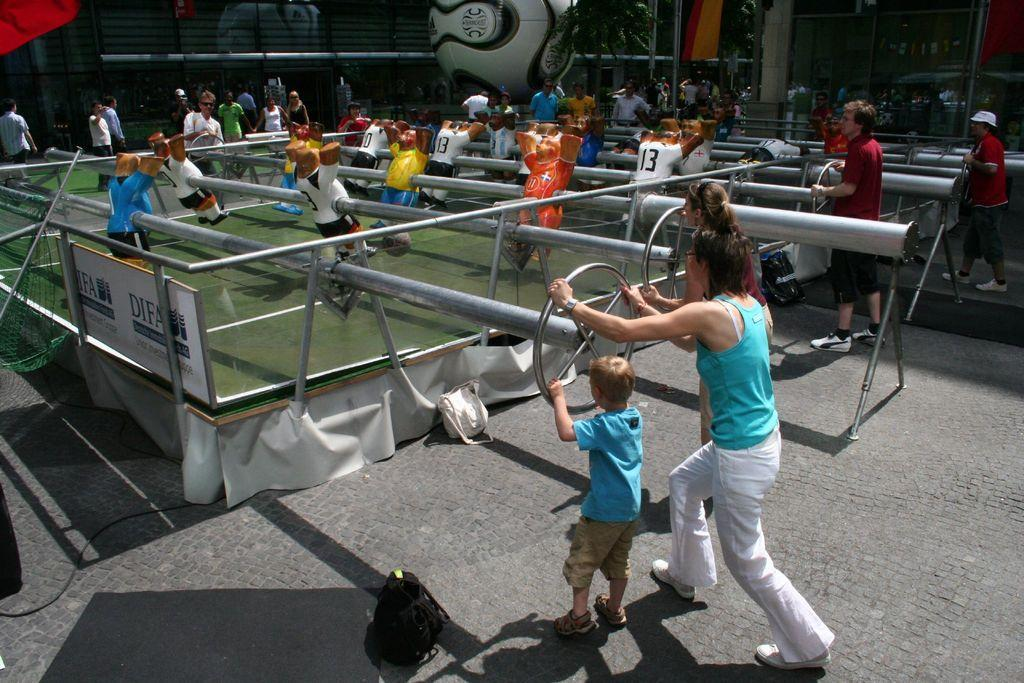How many people are in the image? There is a group of people in the image, but the exact number is not specified. What are the people doing in the image? Some people are playing a game, while others are holding metal rods. What can be seen in the background of the image? There is a tree and buildings in the background of the image. What object is present in the image that is commonly used in games? There is a ball in the image. What direction is the fog coming from in the image? There is no fog present in the image, so it is not possible to determine the direction it might be coming from. 